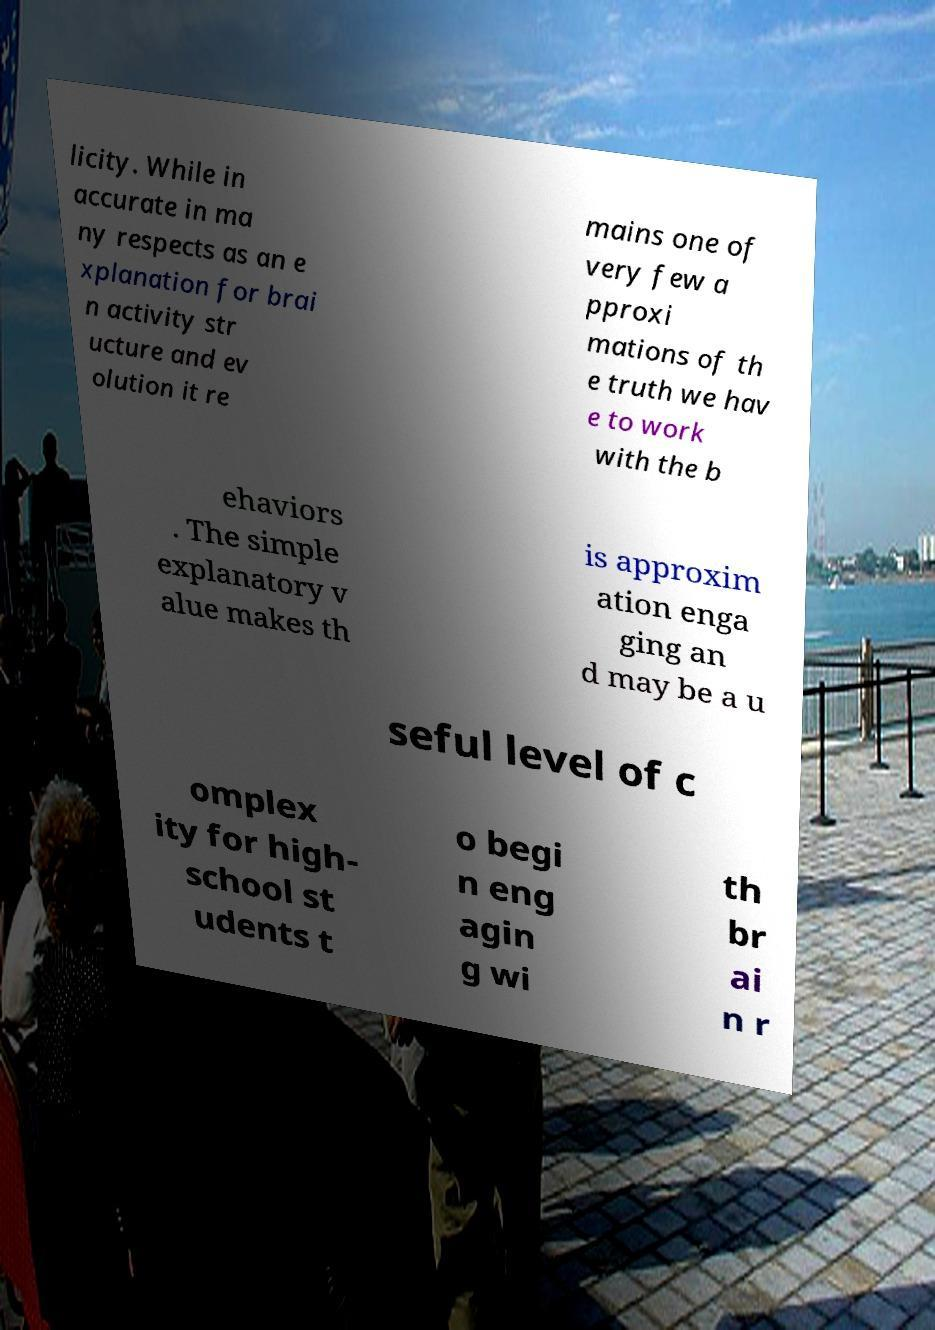Can you accurately transcribe the text from the provided image for me? licity. While in accurate in ma ny respects as an e xplanation for brai n activity str ucture and ev olution it re mains one of very few a pproxi mations of th e truth we hav e to work with the b ehaviors . The simple explanatory v alue makes th is approxim ation enga ging an d may be a u seful level of c omplex ity for high- school st udents t o begi n eng agin g wi th br ai n r 